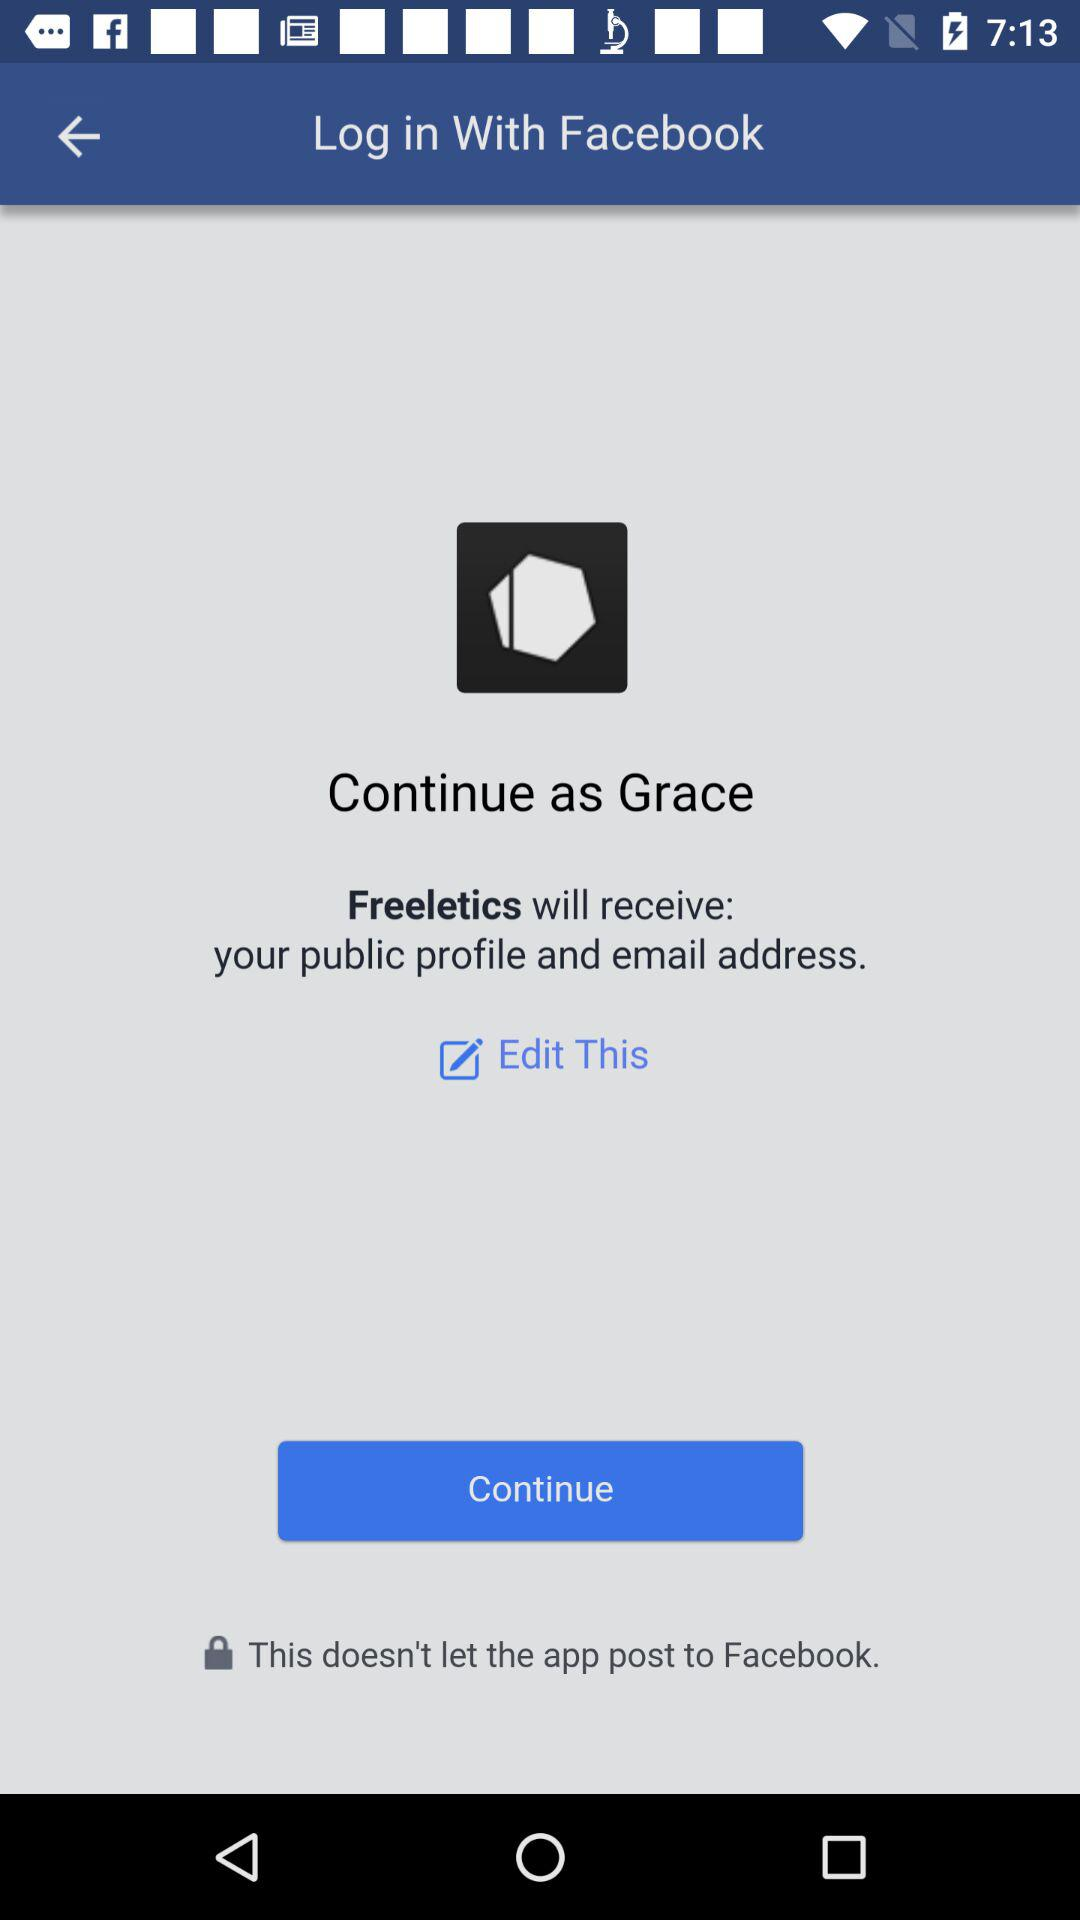Which application is asking for permission? The application that is asking for permission is "Freeletics". 